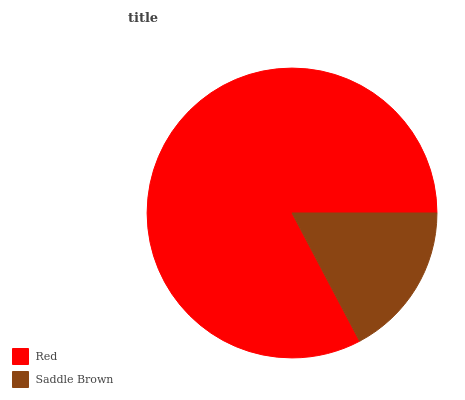Is Saddle Brown the minimum?
Answer yes or no. Yes. Is Red the maximum?
Answer yes or no. Yes. Is Saddle Brown the maximum?
Answer yes or no. No. Is Red greater than Saddle Brown?
Answer yes or no. Yes. Is Saddle Brown less than Red?
Answer yes or no. Yes. Is Saddle Brown greater than Red?
Answer yes or no. No. Is Red less than Saddle Brown?
Answer yes or no. No. Is Red the high median?
Answer yes or no. Yes. Is Saddle Brown the low median?
Answer yes or no. Yes. Is Saddle Brown the high median?
Answer yes or no. No. Is Red the low median?
Answer yes or no. No. 